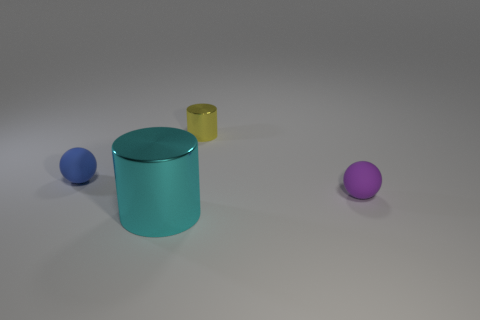There is a tiny matte object in front of the small blue rubber sphere; what color is it?
Your answer should be very brief. Purple. What material is the tiny ball in front of the rubber sphere that is on the left side of the matte ball right of the tiny shiny cylinder?
Provide a succinct answer. Rubber. Is there a small purple object that has the same shape as the tiny blue rubber thing?
Provide a succinct answer. Yes. What is the shape of the blue object that is the same size as the purple matte ball?
Keep it short and to the point. Sphere. What number of things are on the left side of the cyan metal cylinder and to the right of the yellow cylinder?
Keep it short and to the point. 0. Are there fewer balls right of the tiny purple rubber ball than big yellow balls?
Give a very brief answer. No. Are there any cyan shiny objects that have the same size as the yellow thing?
Give a very brief answer. No. The sphere that is the same material as the purple object is what color?
Give a very brief answer. Blue. There is a cylinder that is in front of the tiny yellow object; how many tiny matte objects are right of it?
Provide a succinct answer. 1. What is the tiny thing that is to the right of the cyan metallic object and to the left of the small purple ball made of?
Offer a terse response. Metal. 